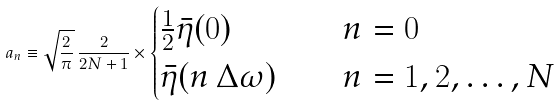<formula> <loc_0><loc_0><loc_500><loc_500>a _ { n } \equiv \sqrt { \frac { 2 } { \pi } } \, \frac { 2 } { 2 N + 1 } \times \begin{cases} \frac { 1 } { 2 } \bar { \eta } ( 0 ) & \quad n = 0 \\ \bar { \eta } ( n \, \Delta \omega ) & \quad n = 1 , 2 , \dots , N \end{cases}</formula> 